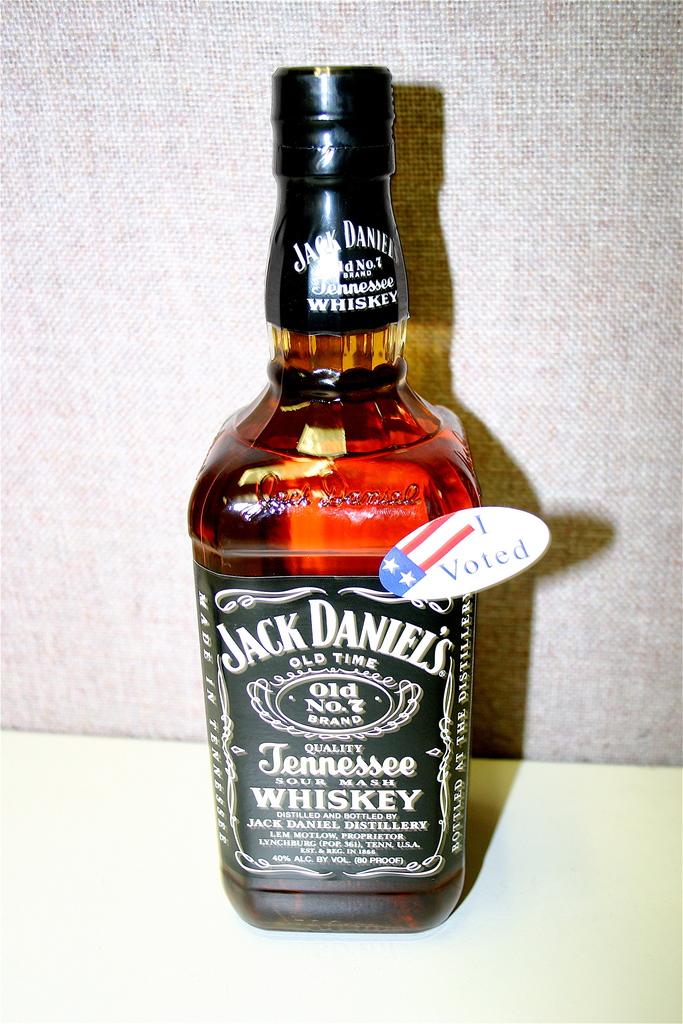What kind of whiskey is this?
Provide a succinct answer. Jack daniels. 